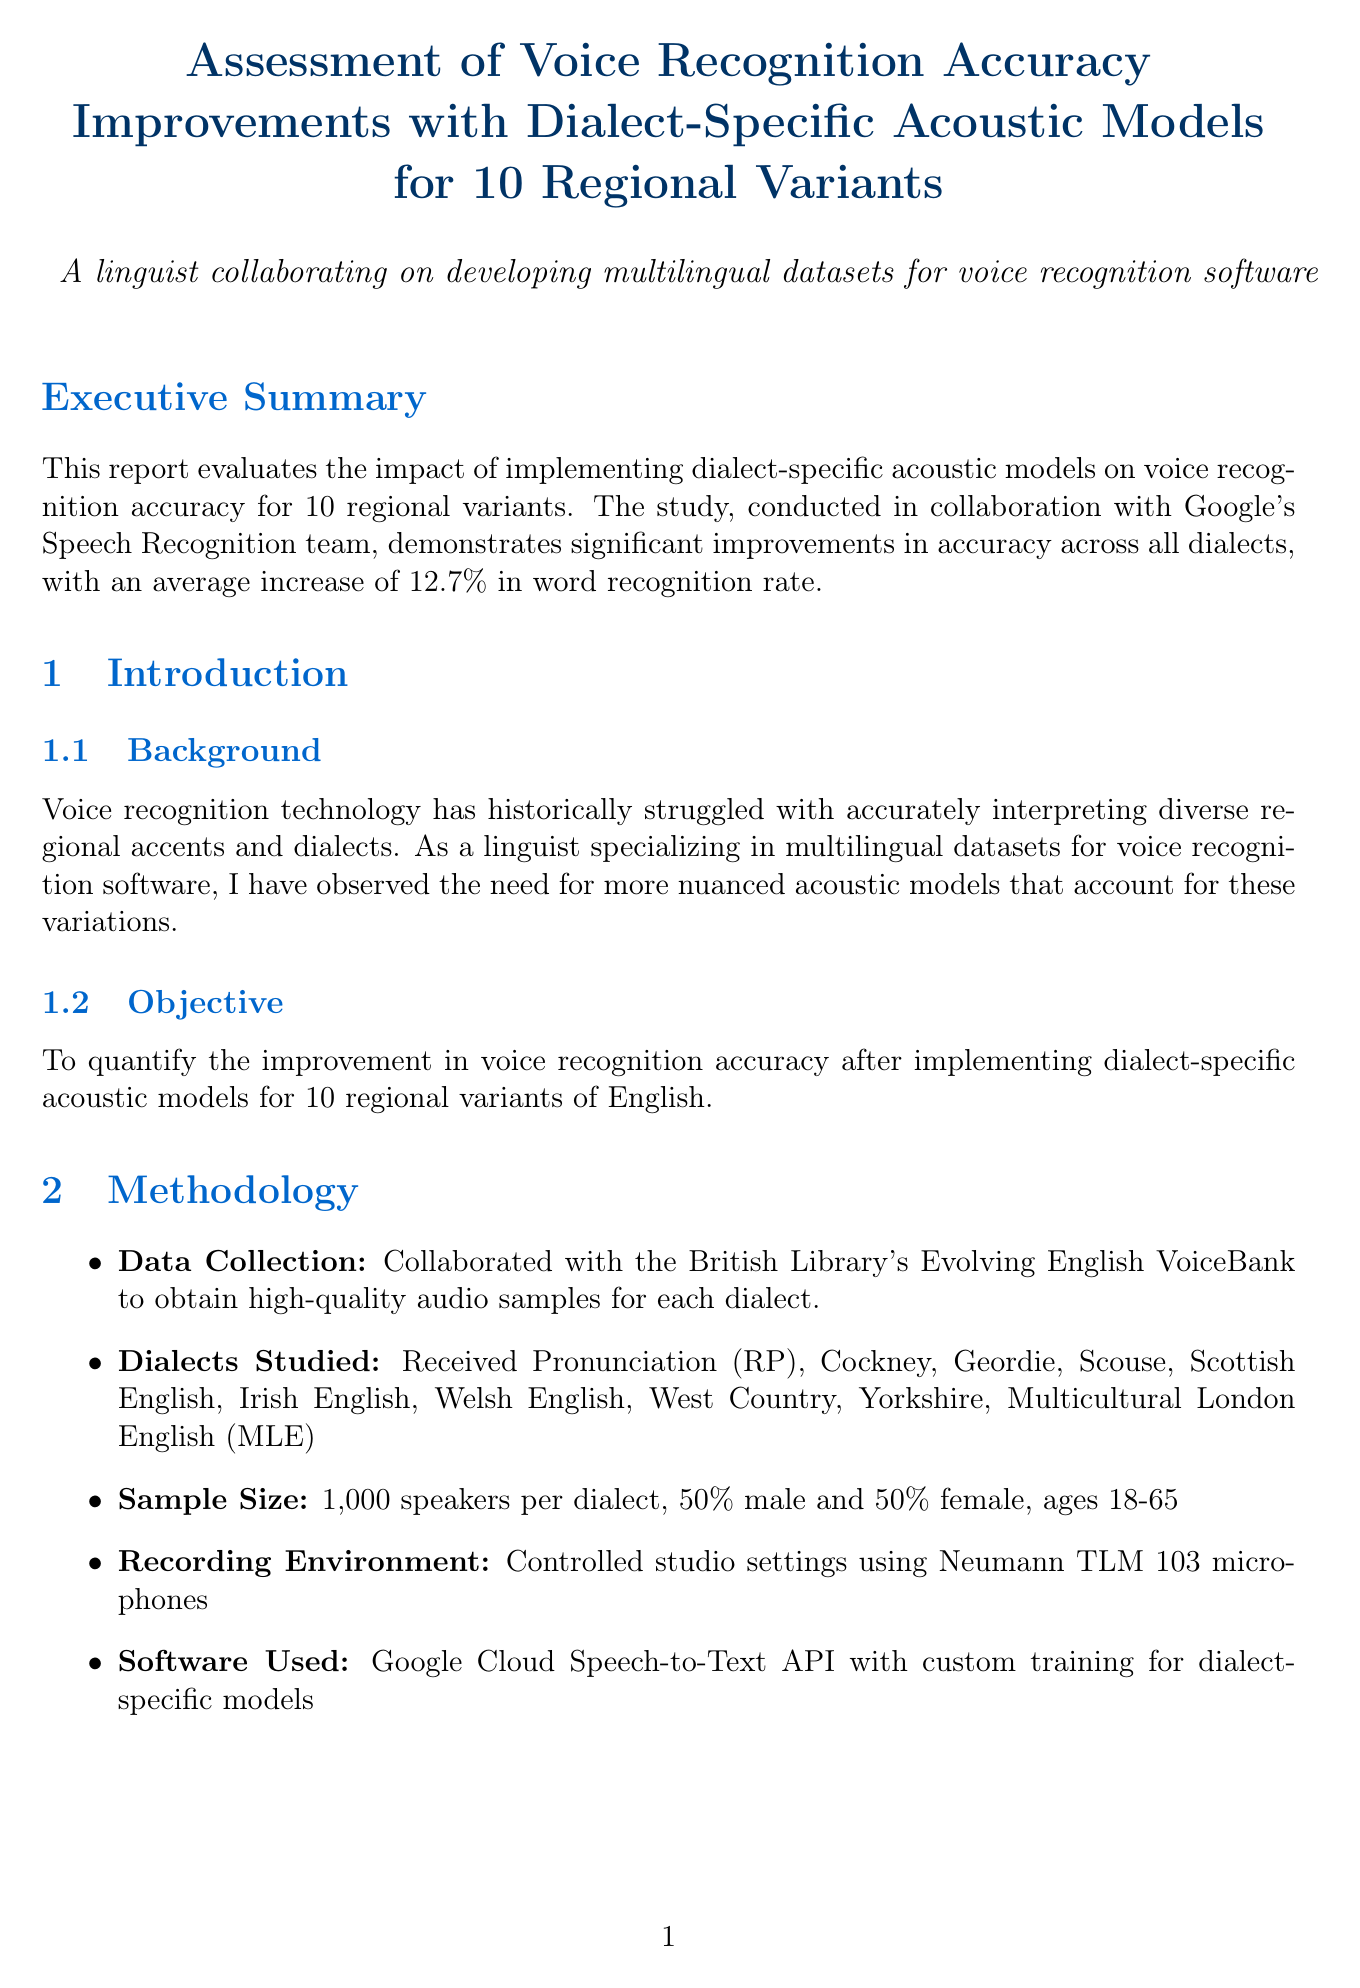What is the average increase in word recognition rate? The report states that the average increase in word recognition rate across all dialects is 12.7%.
Answer: 12.7% Which dialect showed the most significant improvement? The document notes that Geordie dialect showed the most significant improvement with an increase of 18.7%.
Answer: Geordie How many speakers were involved in the study per dialect? The document mentions a sample size of 1,000 speakers per dialect.
Answer: 1,000 speakers What was the average reduction in word error rate across all dialects? The report specifies a 22.3% average reduction in word error rate across all dialects.
Answer: 22.3% What is one of the key findings regarding Received Pronunciation? The discussion highlights that RP had the smallest improvement as it was already well-represented in standard acoustic models.
Answer: Smallest improvement How many regional dialects were studied in total? The report lists the dialects studied, totaling 10 regional variants.
Answer: 10 What are the implications of the study? The document discusses implications such as enhanced user experience for speakers of regional dialects and improved accessibility.
Answer: Enhanced user experience Which software was used for the voice recognition models? The report states that the Google Cloud Speech-to-Text API was used with custom training for dialect-specific models.
Answer: Google Cloud Speech-to-Text API 